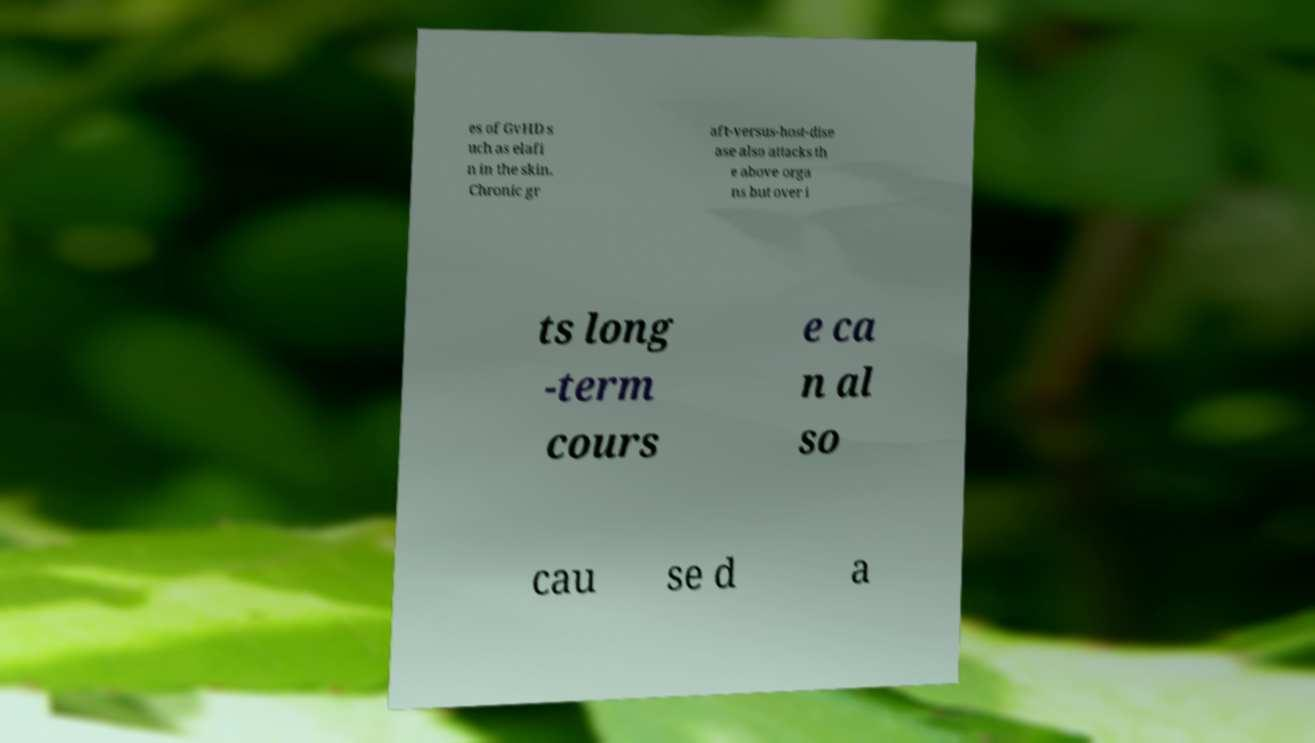Please identify and transcribe the text found in this image. es of GvHD s uch as elafi n in the skin. Chronic gr aft-versus-host-dise ase also attacks th e above orga ns but over i ts long -term cours e ca n al so cau se d a 